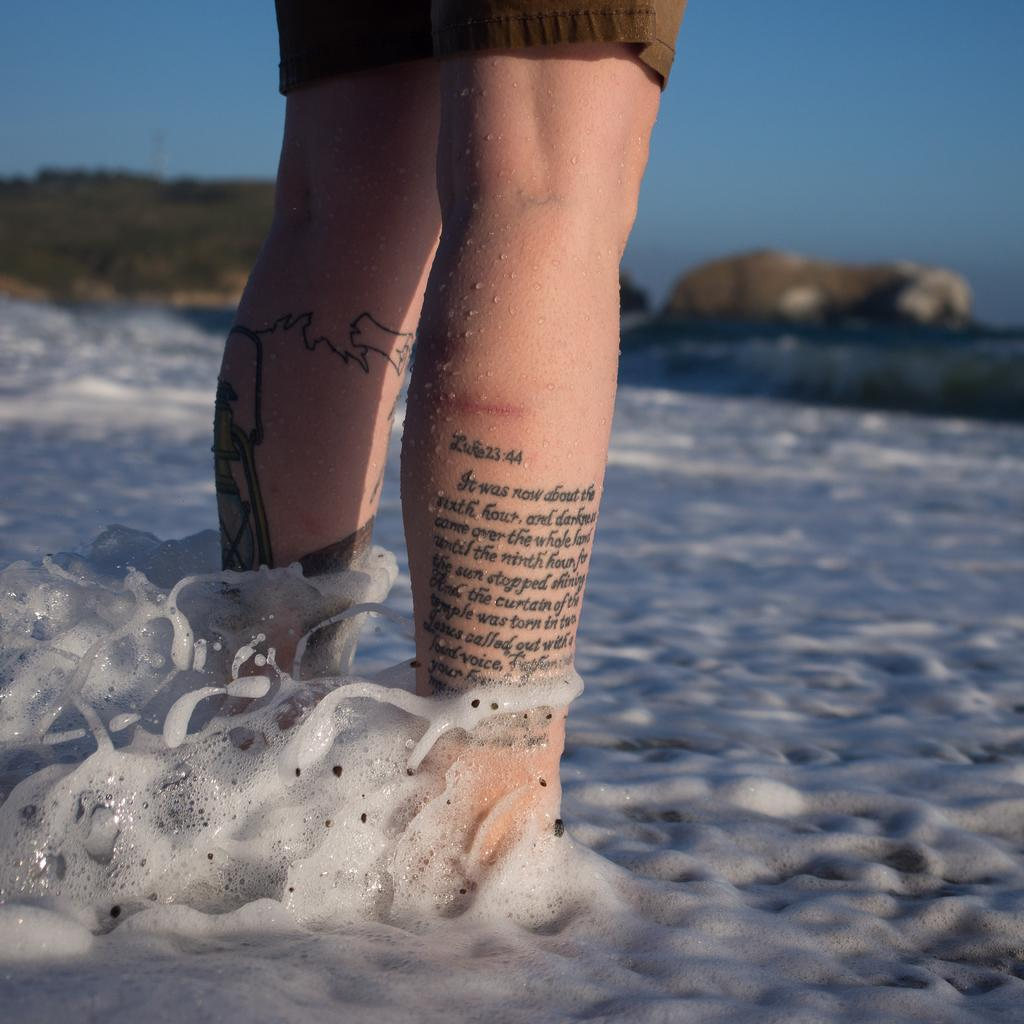What is the main subject of the image? There is a person standing in the center of the image. Can you describe any unique features of the person? There is text written on the leg of the person. What can be seen in the front of the image? There is water visible in the front of the image. What type of drum is the person holding in the image? There is no drum present in the image; the person is standing with text written on their leg and water visible in the front. 